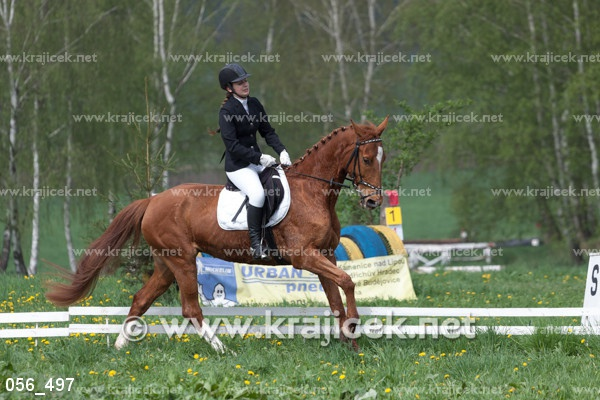Describe the objects in this image and their specific colors. I can see horse in gray, maroon, brown, and black tones and people in gray, black, and white tones in this image. 